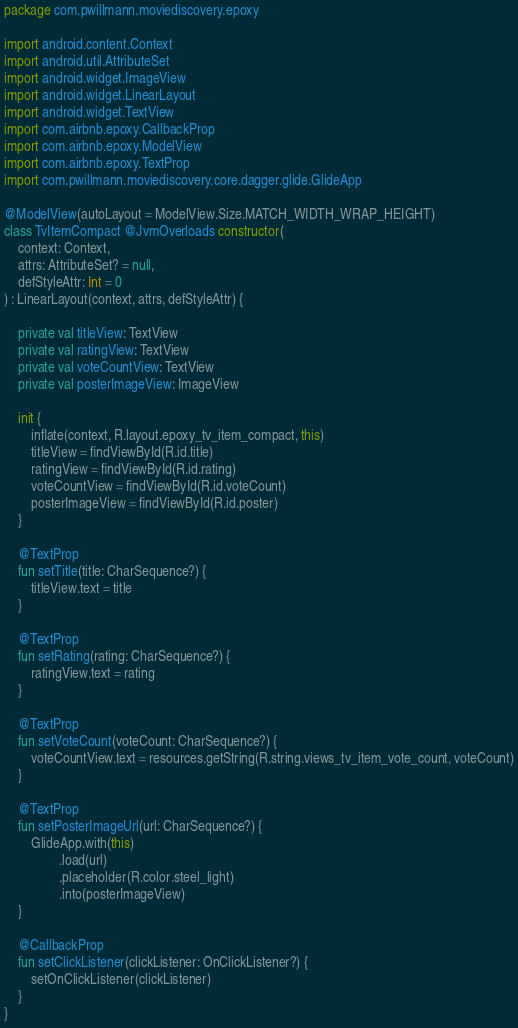Convert code to text. <code><loc_0><loc_0><loc_500><loc_500><_Kotlin_>package com.pwillmann.moviediscovery.epoxy

import android.content.Context
import android.util.AttributeSet
import android.widget.ImageView
import android.widget.LinearLayout
import android.widget.TextView
import com.airbnb.epoxy.CallbackProp
import com.airbnb.epoxy.ModelView
import com.airbnb.epoxy.TextProp
import com.pwillmann.moviediscovery.core.dagger.glide.GlideApp

@ModelView(autoLayout = ModelView.Size.MATCH_WIDTH_WRAP_HEIGHT)
class TvItemCompact @JvmOverloads constructor(
    context: Context,
    attrs: AttributeSet? = null,
    defStyleAttr: Int = 0
) : LinearLayout(context, attrs, defStyleAttr) {

    private val titleView: TextView
    private val ratingView: TextView
    private val voteCountView: TextView
    private val posterImageView: ImageView

    init {
        inflate(context, R.layout.epoxy_tv_item_compact, this)
        titleView = findViewById(R.id.title)
        ratingView = findViewById(R.id.rating)
        voteCountView = findViewById(R.id.voteCount)
        posterImageView = findViewById(R.id.poster)
    }

    @TextProp
    fun setTitle(title: CharSequence?) {
        titleView.text = title
    }

    @TextProp
    fun setRating(rating: CharSequence?) {
        ratingView.text = rating
    }

    @TextProp
    fun setVoteCount(voteCount: CharSequence?) {
        voteCountView.text = resources.getString(R.string.views_tv_item_vote_count, voteCount)
    }

    @TextProp
    fun setPosterImageUrl(url: CharSequence?) {
        GlideApp.with(this)
                .load(url)
                .placeholder(R.color.steel_light)
                .into(posterImageView)
    }

    @CallbackProp
    fun setClickListener(clickListener: OnClickListener?) {
        setOnClickListener(clickListener)
    }
}
</code> 